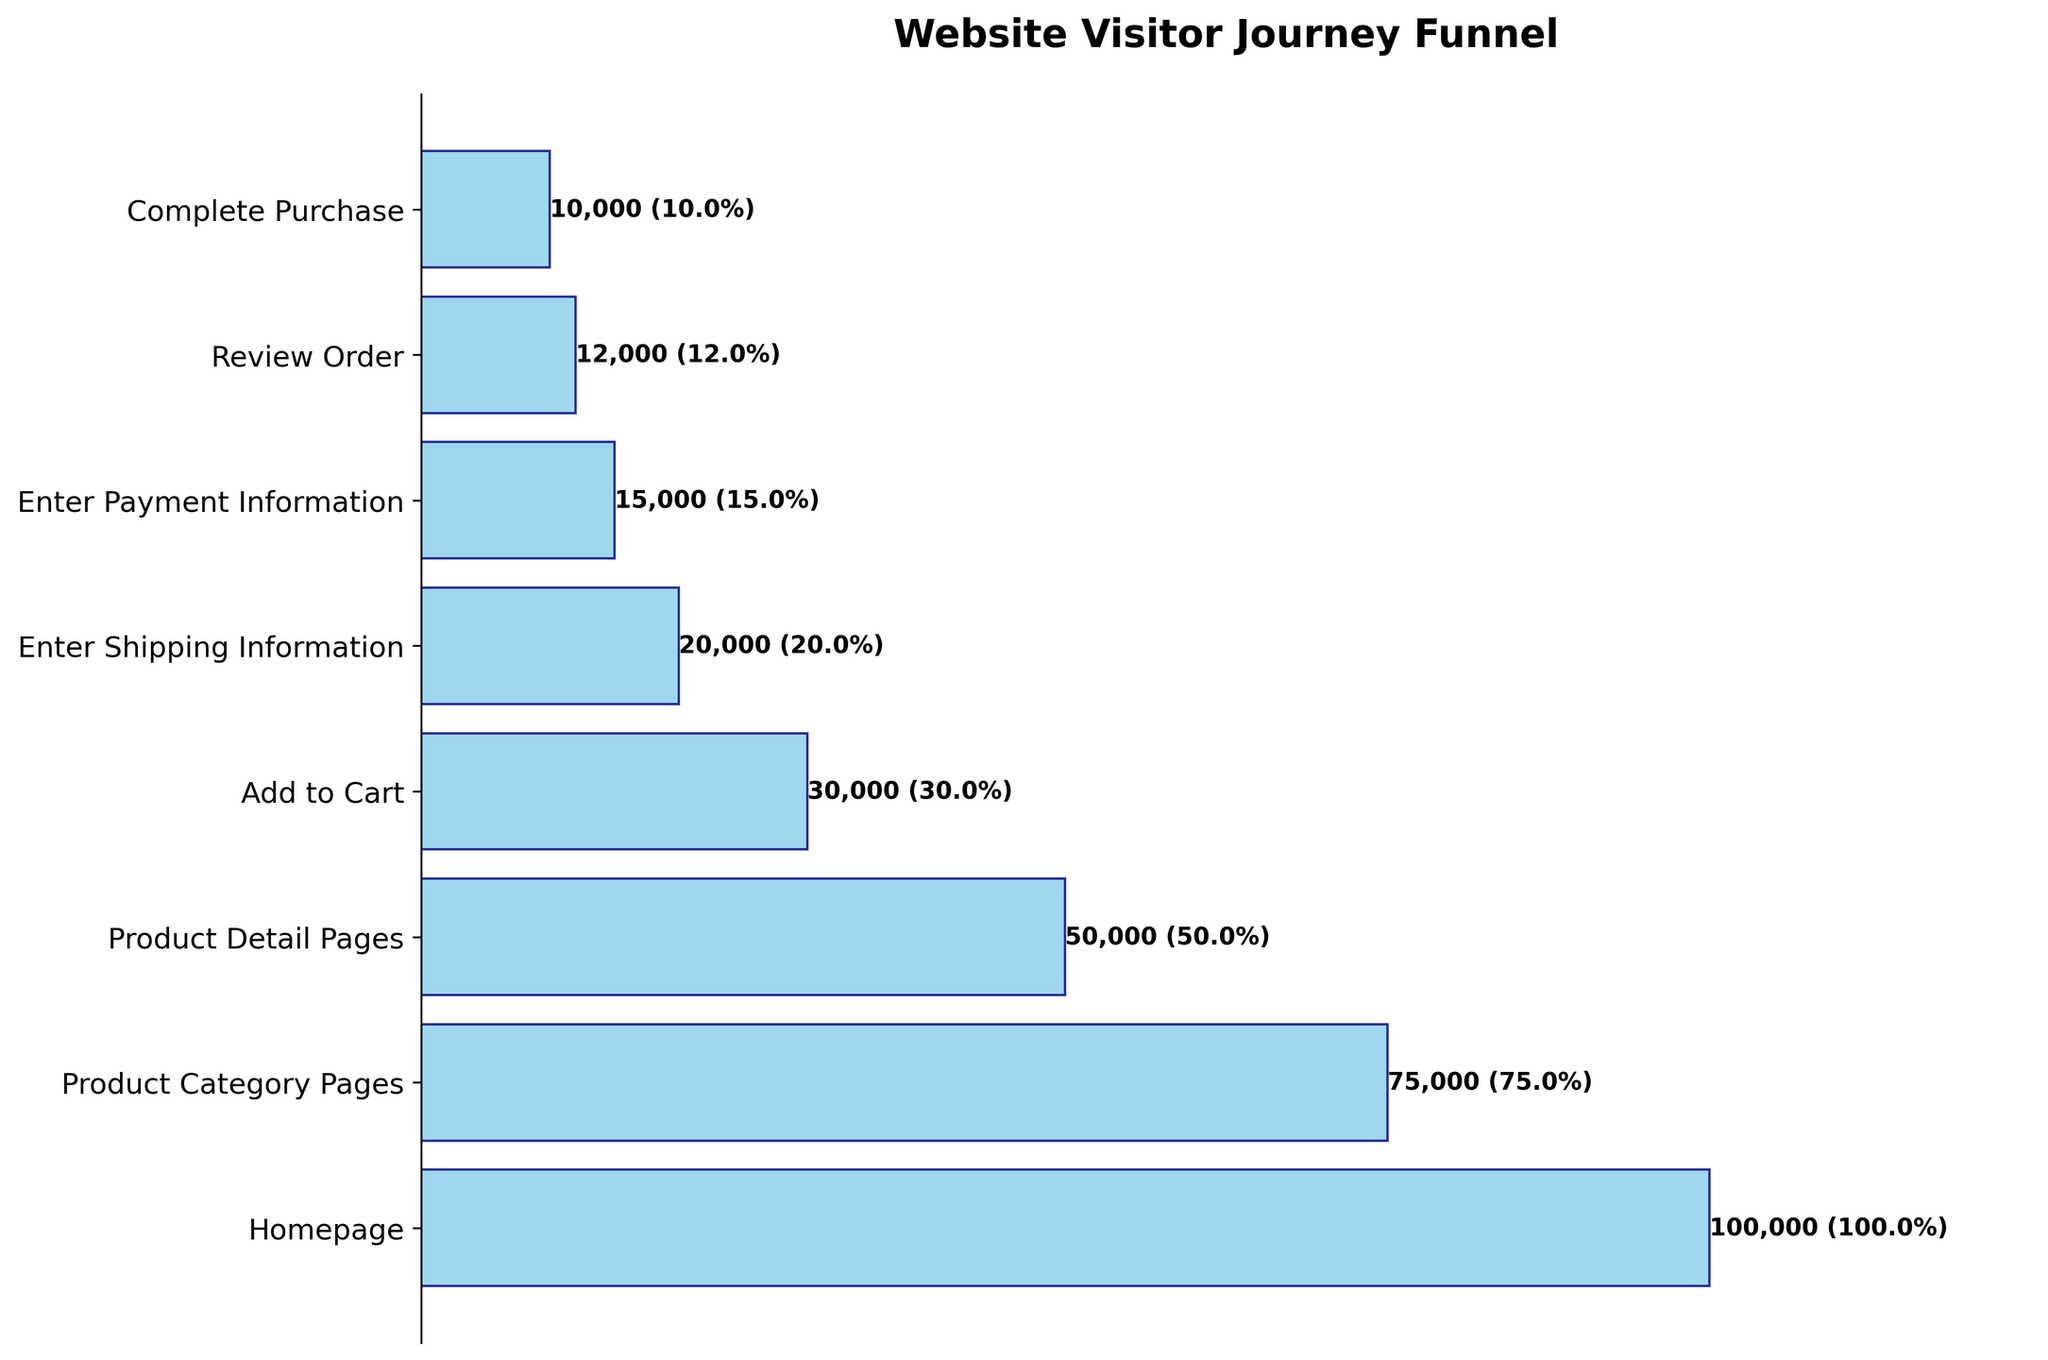What is the total number of visitors that reached the Review Order step? The Review Order step shows an exact number of visitors next to the bar. We can simply read this value off the chart.
Answer: 12,000 What percentage of the visitors from the Homepage step completed a purchase? The Complete Purchase step shows both the number and the percentage of visitors from the Homepage who completed a purchase directly next to the bar.
Answer: 10.0% What is the difference in the number of visitors between the Product Detail Pages and Add to Cart steps? To find the difference, subtract the number of visitors at the Add to Cart step (30,000) from those at the Product Detail Pages step (50,000). 50,000 - 30,000 = 20,000.
Answer: 20,000 Which step has the largest drop-off in visitors compared to the previous step? Calculate the drop-off by subtracting the visitor count of each step from the previous step. Identify the step with the largest difference: 
Homepage to Product Category Pages: 100,000 - 75,000 = 25,000
Product Category Pages to Product Detail Pages: 75,000 - 50,000 = 25,000
Product Detail Pages to Add to Cart: 50,000 - 30,000 = 20,000
Add to Cart to Enter Shipping Information: 30,000 - 20,000 = 10,000
Enter Shipping Information to Enter Payment Information: 20,000 - 15,000 = 5,000
Enter Payment Information to Review Order: 15,000 - 12,000 = 3,000
Review Order to Complete Purchase: 12,000 - 10,000 = 2,000
The largest drop-off is from the Homepage to Product Category Pages or Product Category Pages to Product Detail Pages.
Answer: 25,000 (Homepage to Product Category Pages or Product Category Pages to Product Detail Pages) What percentage of visitors who entered their payment information also completed their purchase? Look at the Enter Payment Information step and the Complete Purchase step. Divide the number of Complete Purchase visitors (10,000) by the number of Enter Payment Information visitors (15,000) and multiply by 100. (10,000 / 15,000) * 100 = 66.7%.
Answer: 66.7% By how much does the number of visitors reduce from Adding to Cart to Entering Shipping Information? Subtract the number of visitors at Enter Shipping Information (20,000) from the number of visitors at Add to Cart (30,000). 30,000 - 20,000 = 10,000.
Answer: 10,000 What is the step with the smallest difference in visitor count compared to the previous step? Calculate the difference for each step pair and identify the smallest one:
Homepage to Product Category Pages: 25,000
Product Category Pages to Product Detail Pages: 25,000
Product Detail Pages to Add to Cart: 20,000
Add to Cart to Enter Shipping Information: 10,000
Enter Shipping Information to Enter Payment Information: 5,000
Enter Payment Information to Review Order: 3,000
Review Order to Complete Purchase: 2,000
The smallest difference is from Review Order to Complete Purchase.
Answer: 2,000 How many visitors are lost between the Product Category Pages step and the Complete Purchase step? Subtract the number of visitors at the Complete Purchase step (10,000) from the number of visitors at the Product Category Pages step (75,000). 75,000 - 10,000 = 65,000.
Answer: 65,000 